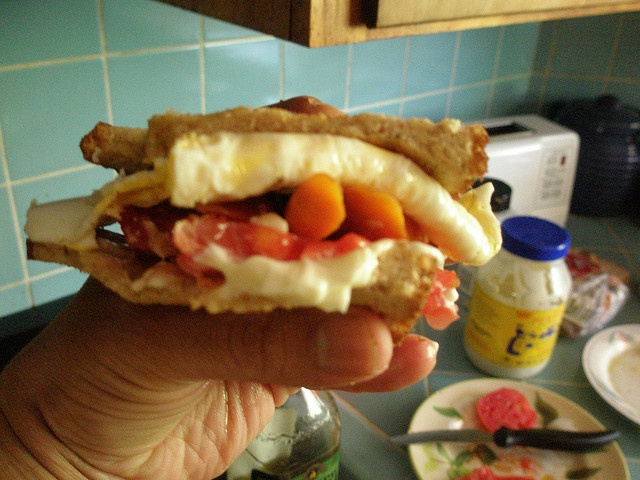Describe the objects in this image and their specific colors. I can see sandwich in teal, olive, maroon, tan, and khaki tones, people in teal, maroon, black, brown, and tan tones, bottle in teal, olive, tan, and navy tones, toaster in teal, lightgray, darkgray, and black tones, and bottle in teal, olive, black, darkgreen, and gray tones in this image. 